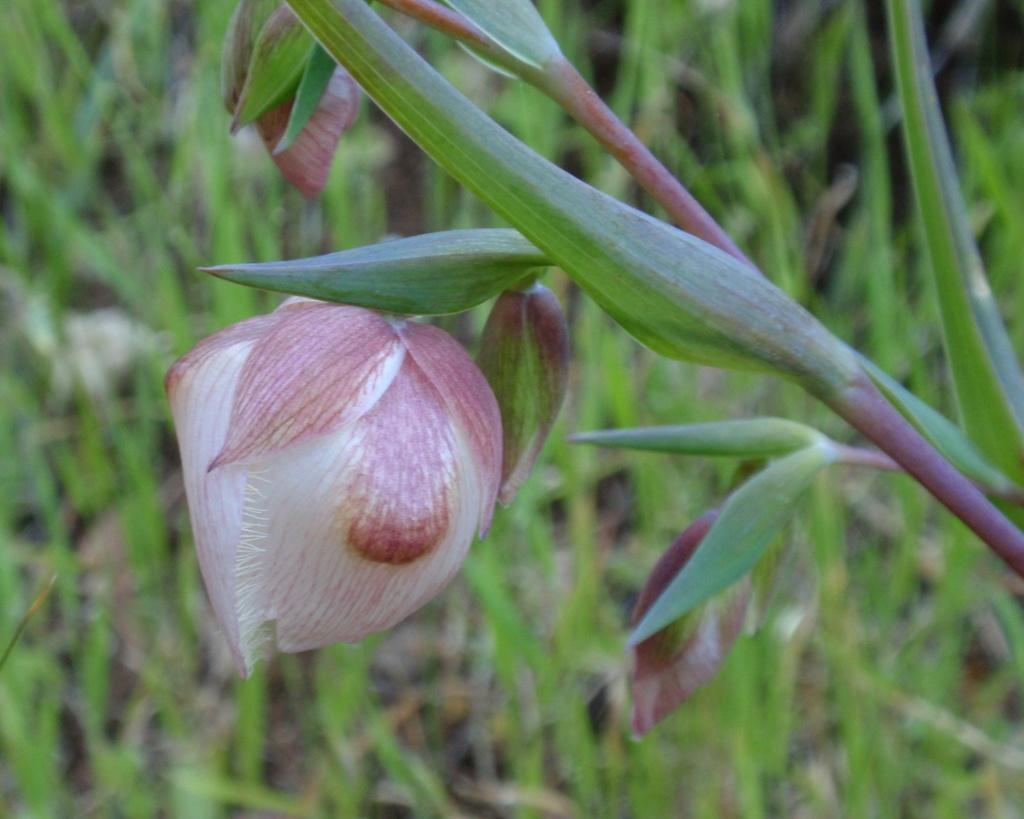What is present in the image? There is a plant in the image. What can be observed about the plant? The plant has a flower in the middle. What is the color of the flower? The flower is white in color. What direction is the plant facing in the image? The direction the plant is facing cannot be determined from the image. Is there a parcel being delivered to the plant in the image? There is no parcel present in the image. 